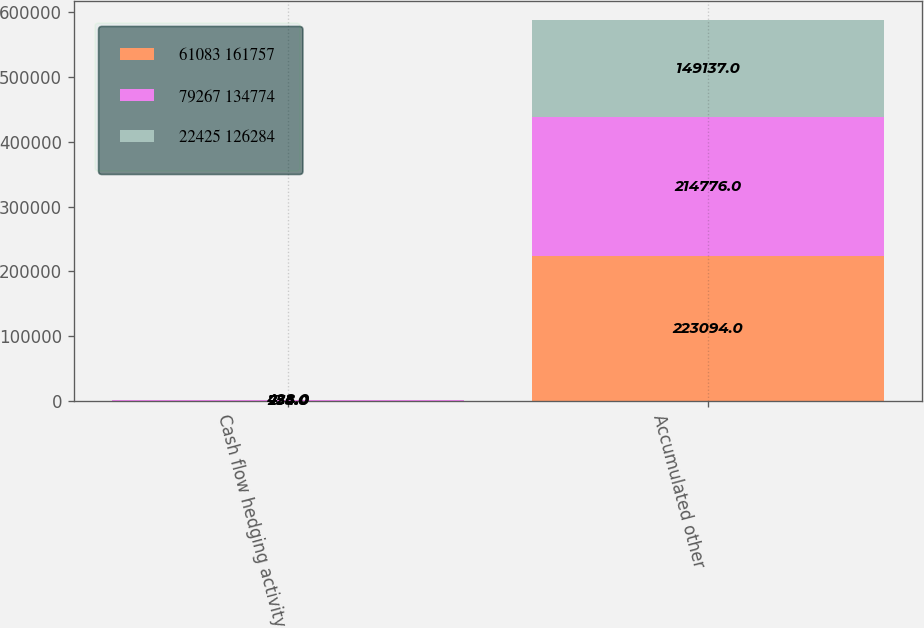<chart> <loc_0><loc_0><loc_500><loc_500><stacked_bar_chart><ecel><fcel>Cash flow hedging activity<fcel>Accumulated other<nl><fcel>61083 161757<fcel>254<fcel>223094<nl><fcel>79267 134774<fcel>735<fcel>214776<nl><fcel>22425 126284<fcel>428<fcel>149137<nl></chart> 